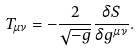Convert formula to latex. <formula><loc_0><loc_0><loc_500><loc_500>T _ { \mu \nu } = - \frac { 2 } { \sqrt { - g } } \frac { \delta S } { \delta g ^ { \mu \nu } } .</formula> 